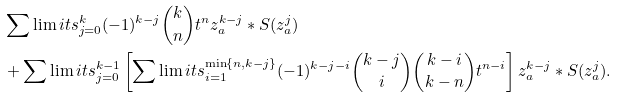Convert formula to latex. <formula><loc_0><loc_0><loc_500><loc_500>& \sum \lim i t s _ { j = 0 } ^ { k } ( - 1 ) ^ { k - j } \binom { k } { n } t ^ { n } z _ { a } ^ { k - j } \ast S ( z _ { a } ^ { j } ) \\ & + \sum \lim i t s _ { j = 0 } ^ { k - 1 } \left [ \sum \lim i t s _ { i = 1 } ^ { \min \{ n , k - j \} } ( - 1 ) ^ { k - j - i } \binom { k - j } { i } \binom { k - i } { k - n } t ^ { n - i } \right ] z _ { a } ^ { k - j } \ast S ( z _ { a } ^ { j } ) .</formula> 